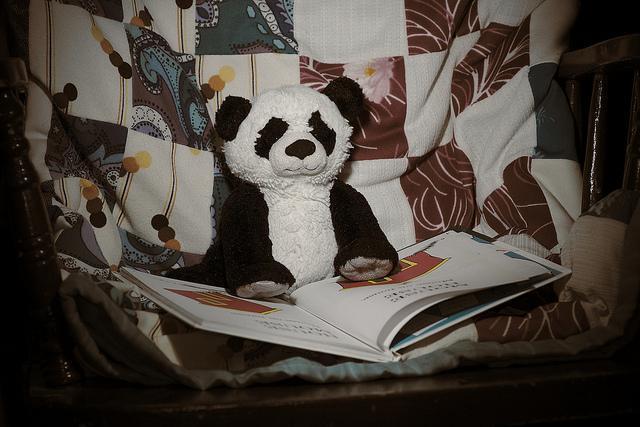Where do pandas come from?
Pick the correct solution from the four options below to address the question.
Options: Japan, china, mongolia, taiwan. China. 